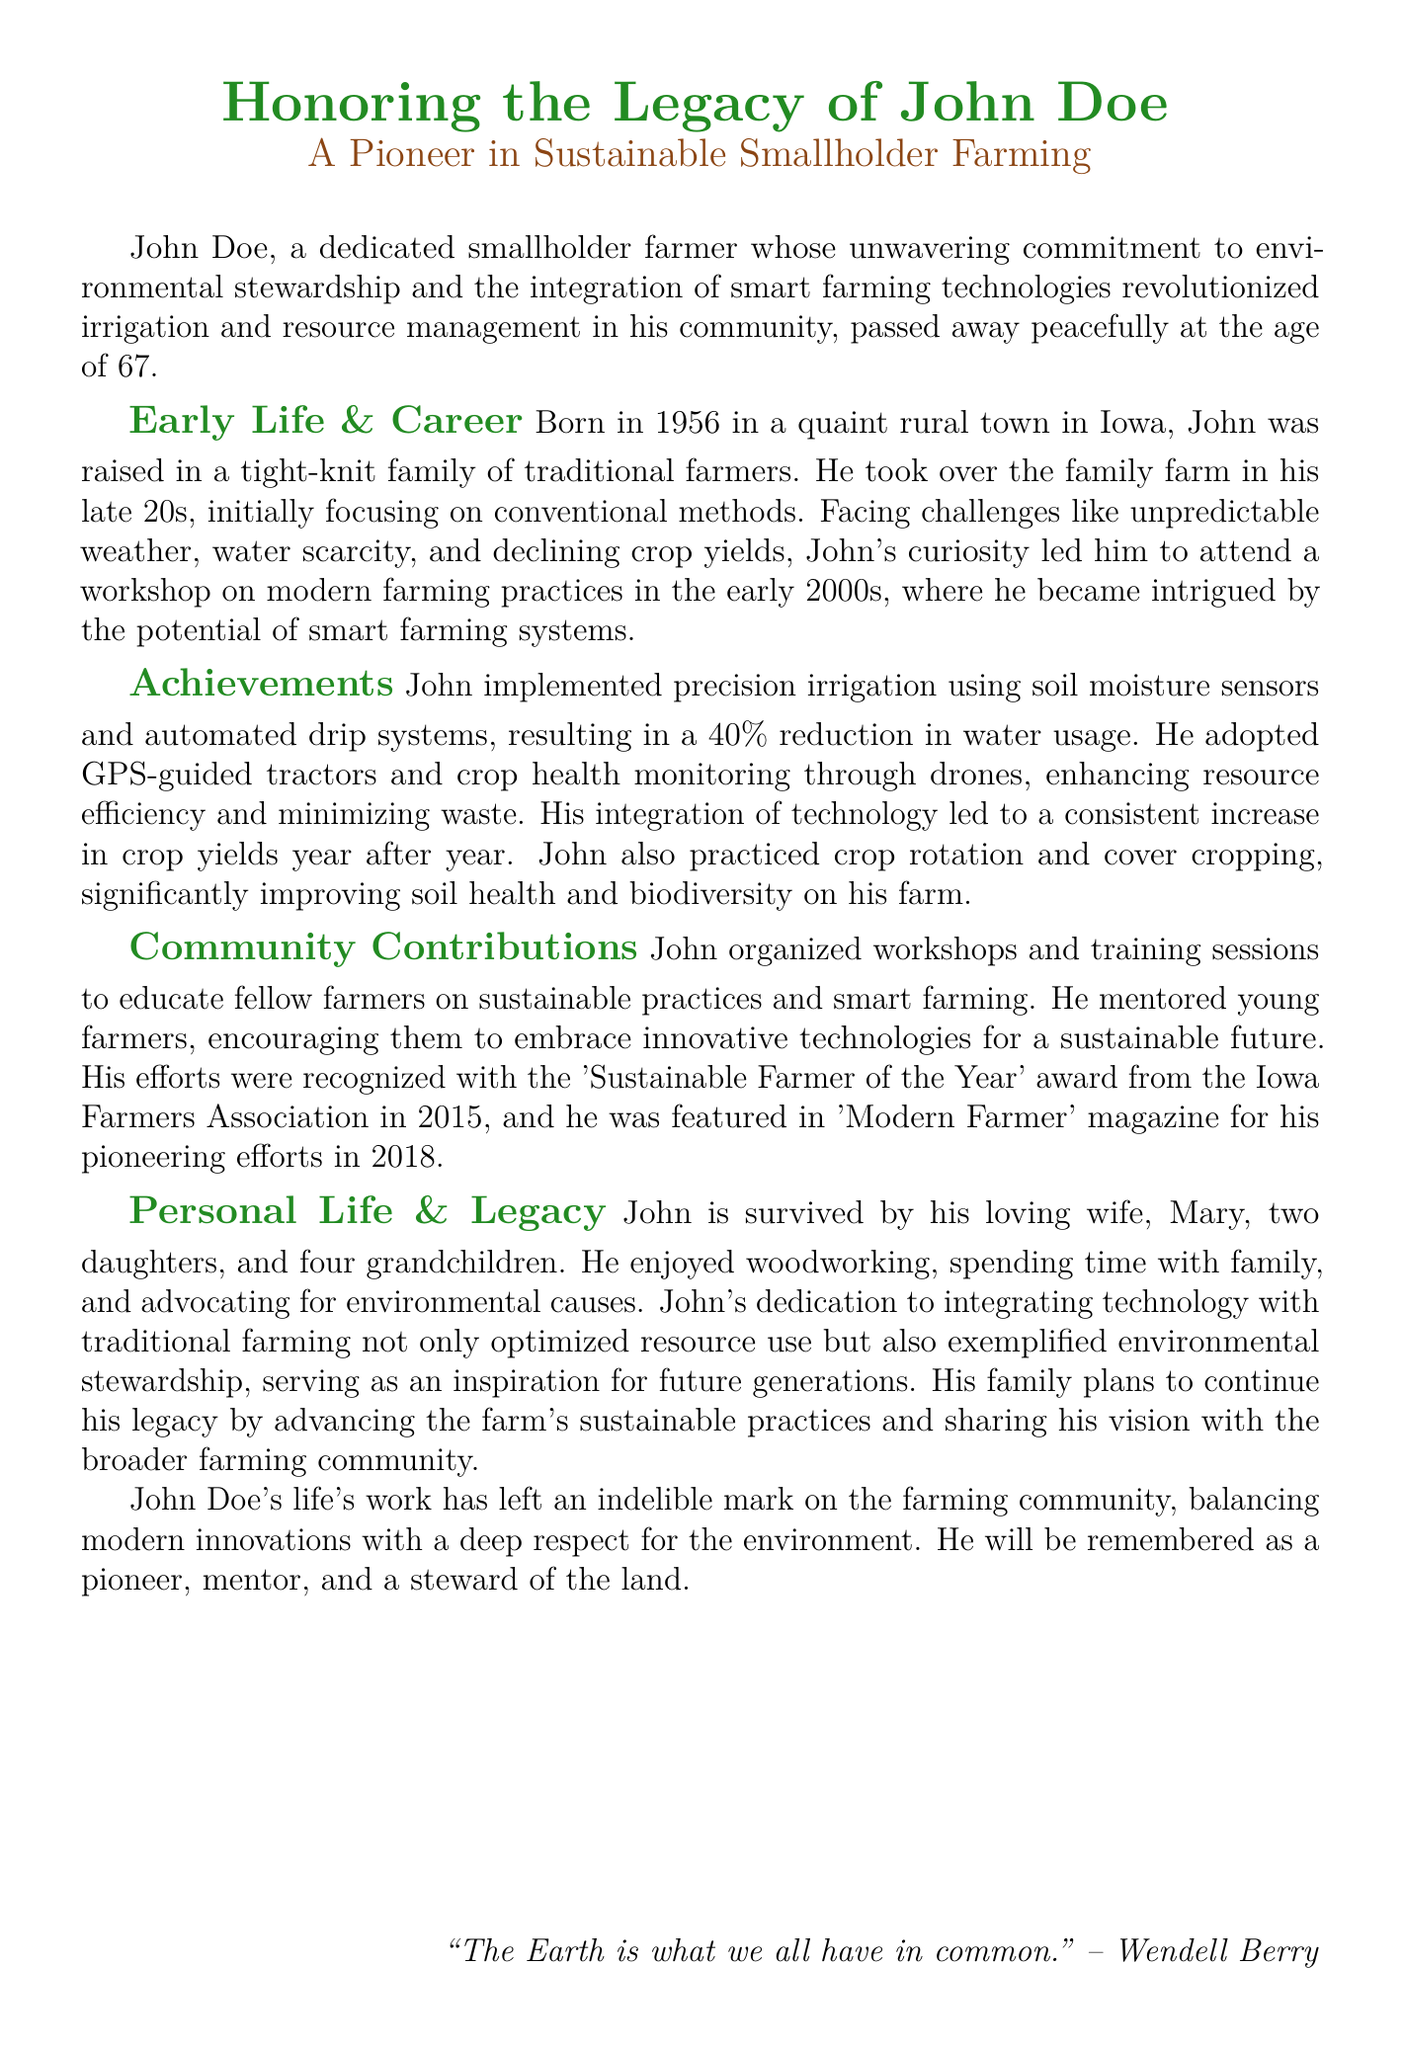What was John Doe's age at the time of passing? The document states that he passed away at the age of 67.
Answer: 67 What significant award did John receive in 2015? The document mentions he was recognized with the 'Sustainable Farmer of the Year' award.
Answer: Sustainable Farmer of the Year What percentage reduction in water usage did John's irrigation system achieve? The document indicates that John achieved a 40% reduction in water usage.
Answer: 40% What type of farm technology did John use to monitor crop health? The document refers to drones being used for crop health monitoring.
Answer: Drones In what year did John attend the workshop on modern farming practices? The document states he attended the workshop in the early 2000s.
Answer: Early 2000s What did John enjoy doing in his personal life besides farming? The document mentions that he enjoyed woodworking.
Answer: Woodworking What did John advocate for in addition to modern farming practices? The document refers to his advocacy for environmental causes.
Answer: Environmental causes What was one of the sustainable practices John promoted among fellow farmers? The document says he organized workshops to educate on sustainable practices.
Answer: Workshops What was John's legacy for future generations? The document states that he served as an inspiration for future generations.
Answer: Inspiration for future generations 